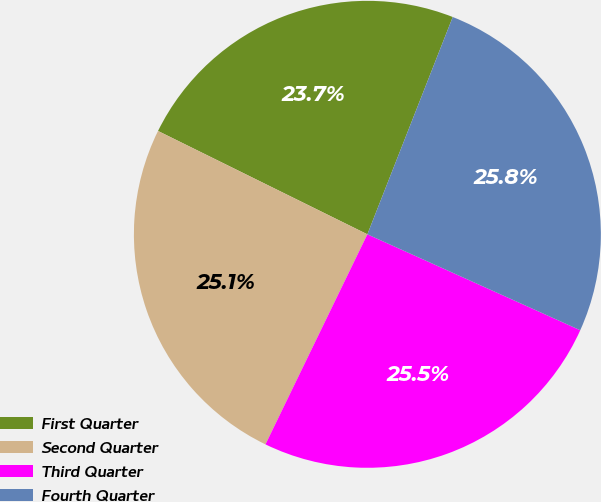<chart> <loc_0><loc_0><loc_500><loc_500><pie_chart><fcel>First Quarter<fcel>Second Quarter<fcel>Third Quarter<fcel>Fourth Quarter<nl><fcel>23.66%<fcel>25.11%<fcel>25.45%<fcel>25.78%<nl></chart> 